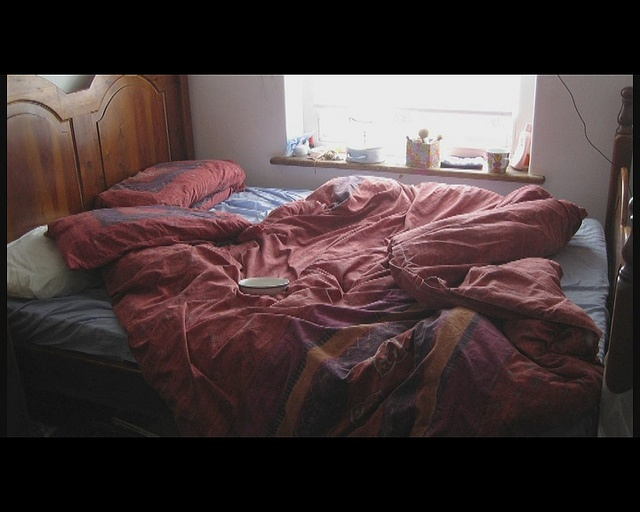Describe the objects in this image and their specific colors. I can see bed in black, maroon, and brown tones, bowl in black, darkgray, brown, and maroon tones, and cup in black, darkgray, brown, gray, and lightgray tones in this image. 